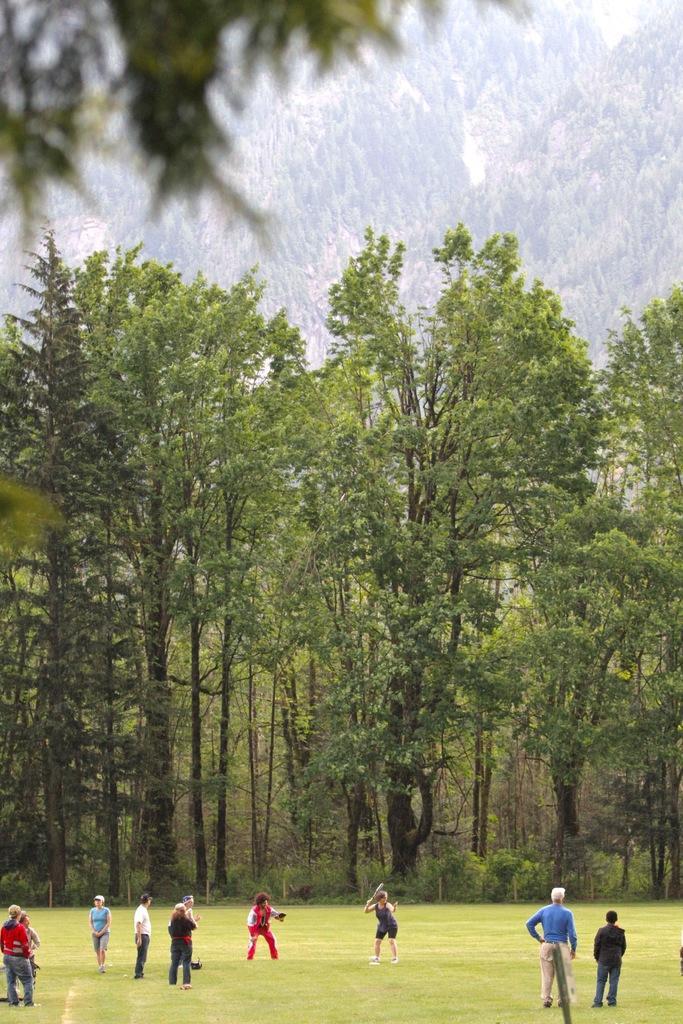Please provide a concise description of this image. In this image we can see people are playing on the grassy land. Background of the image, we can see trees. 